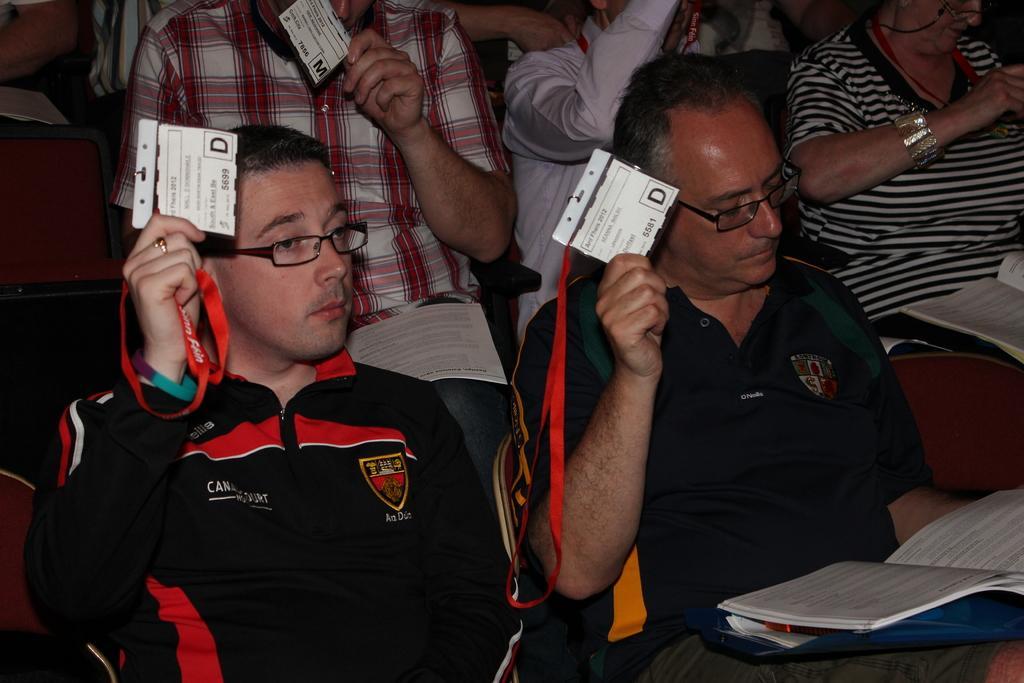In one or two sentences, can you explain what this image depicts? In this image I can see people are sitting on chairs among them some are holding ID cards in their hands. Here I can see a book on a man. 